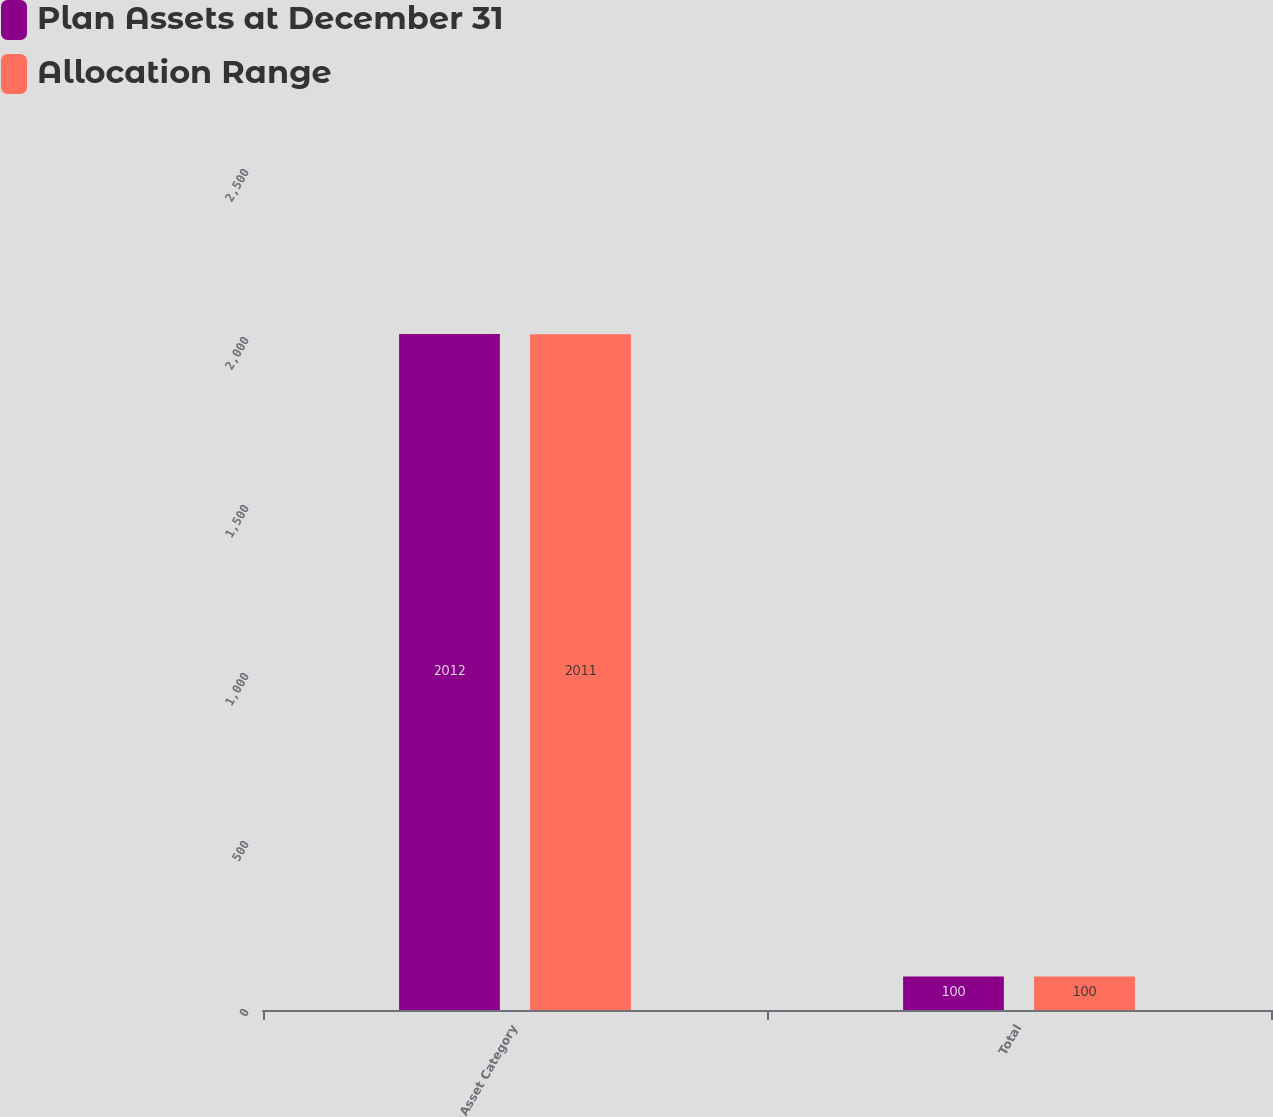Convert chart. <chart><loc_0><loc_0><loc_500><loc_500><stacked_bar_chart><ecel><fcel>Asset Category<fcel>Total<nl><fcel>Plan Assets at December 31<fcel>2012<fcel>100<nl><fcel>Allocation Range<fcel>2011<fcel>100<nl></chart> 